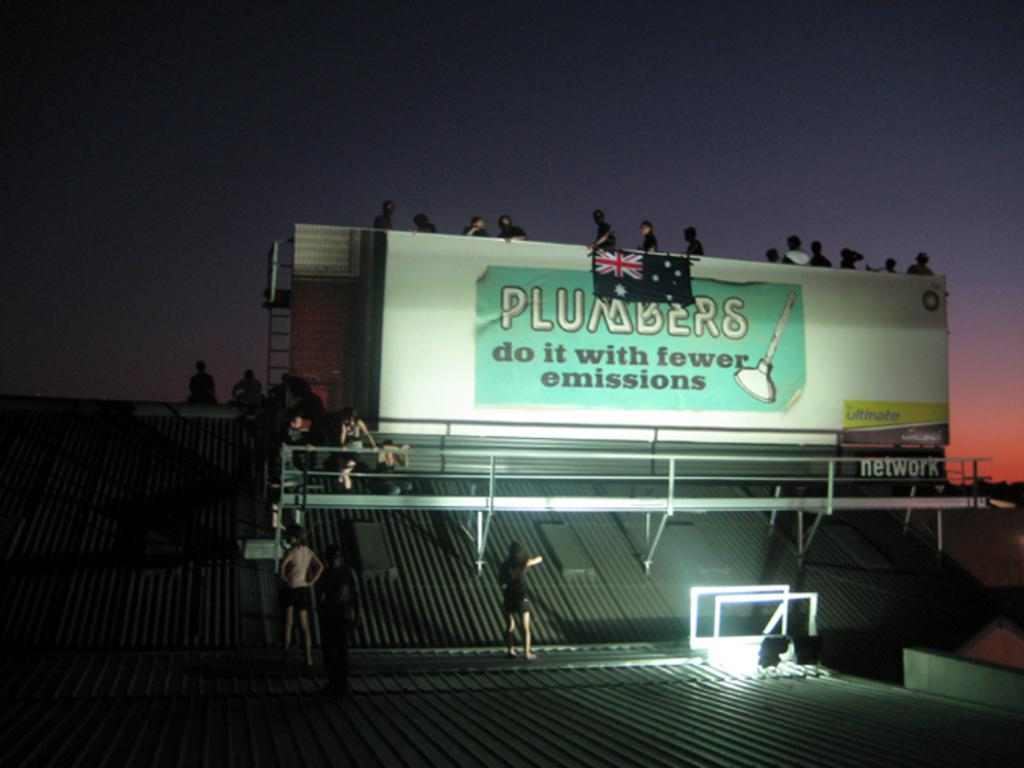<image>
Give a short and clear explanation of the subsequent image. A billboard that says plumbers do it with fewer emissions. 